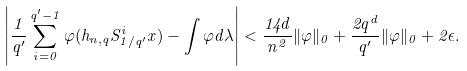<formula> <loc_0><loc_0><loc_500><loc_500>\left | \frac { 1 } { q ^ { \prime } } \sum _ { i = 0 } ^ { q ^ { \prime } - 1 } \varphi ( h _ { n , q } S _ { 1 / q ^ { \prime } } ^ { i } x ) - \int \varphi d \lambda \right | < \frac { 1 4 d } { n ^ { 2 } } \| \varphi \| _ { 0 } + \frac { 2 q ^ { d } } { q ^ { \prime } } \| \varphi \| _ { 0 } + 2 \epsilon .</formula> 